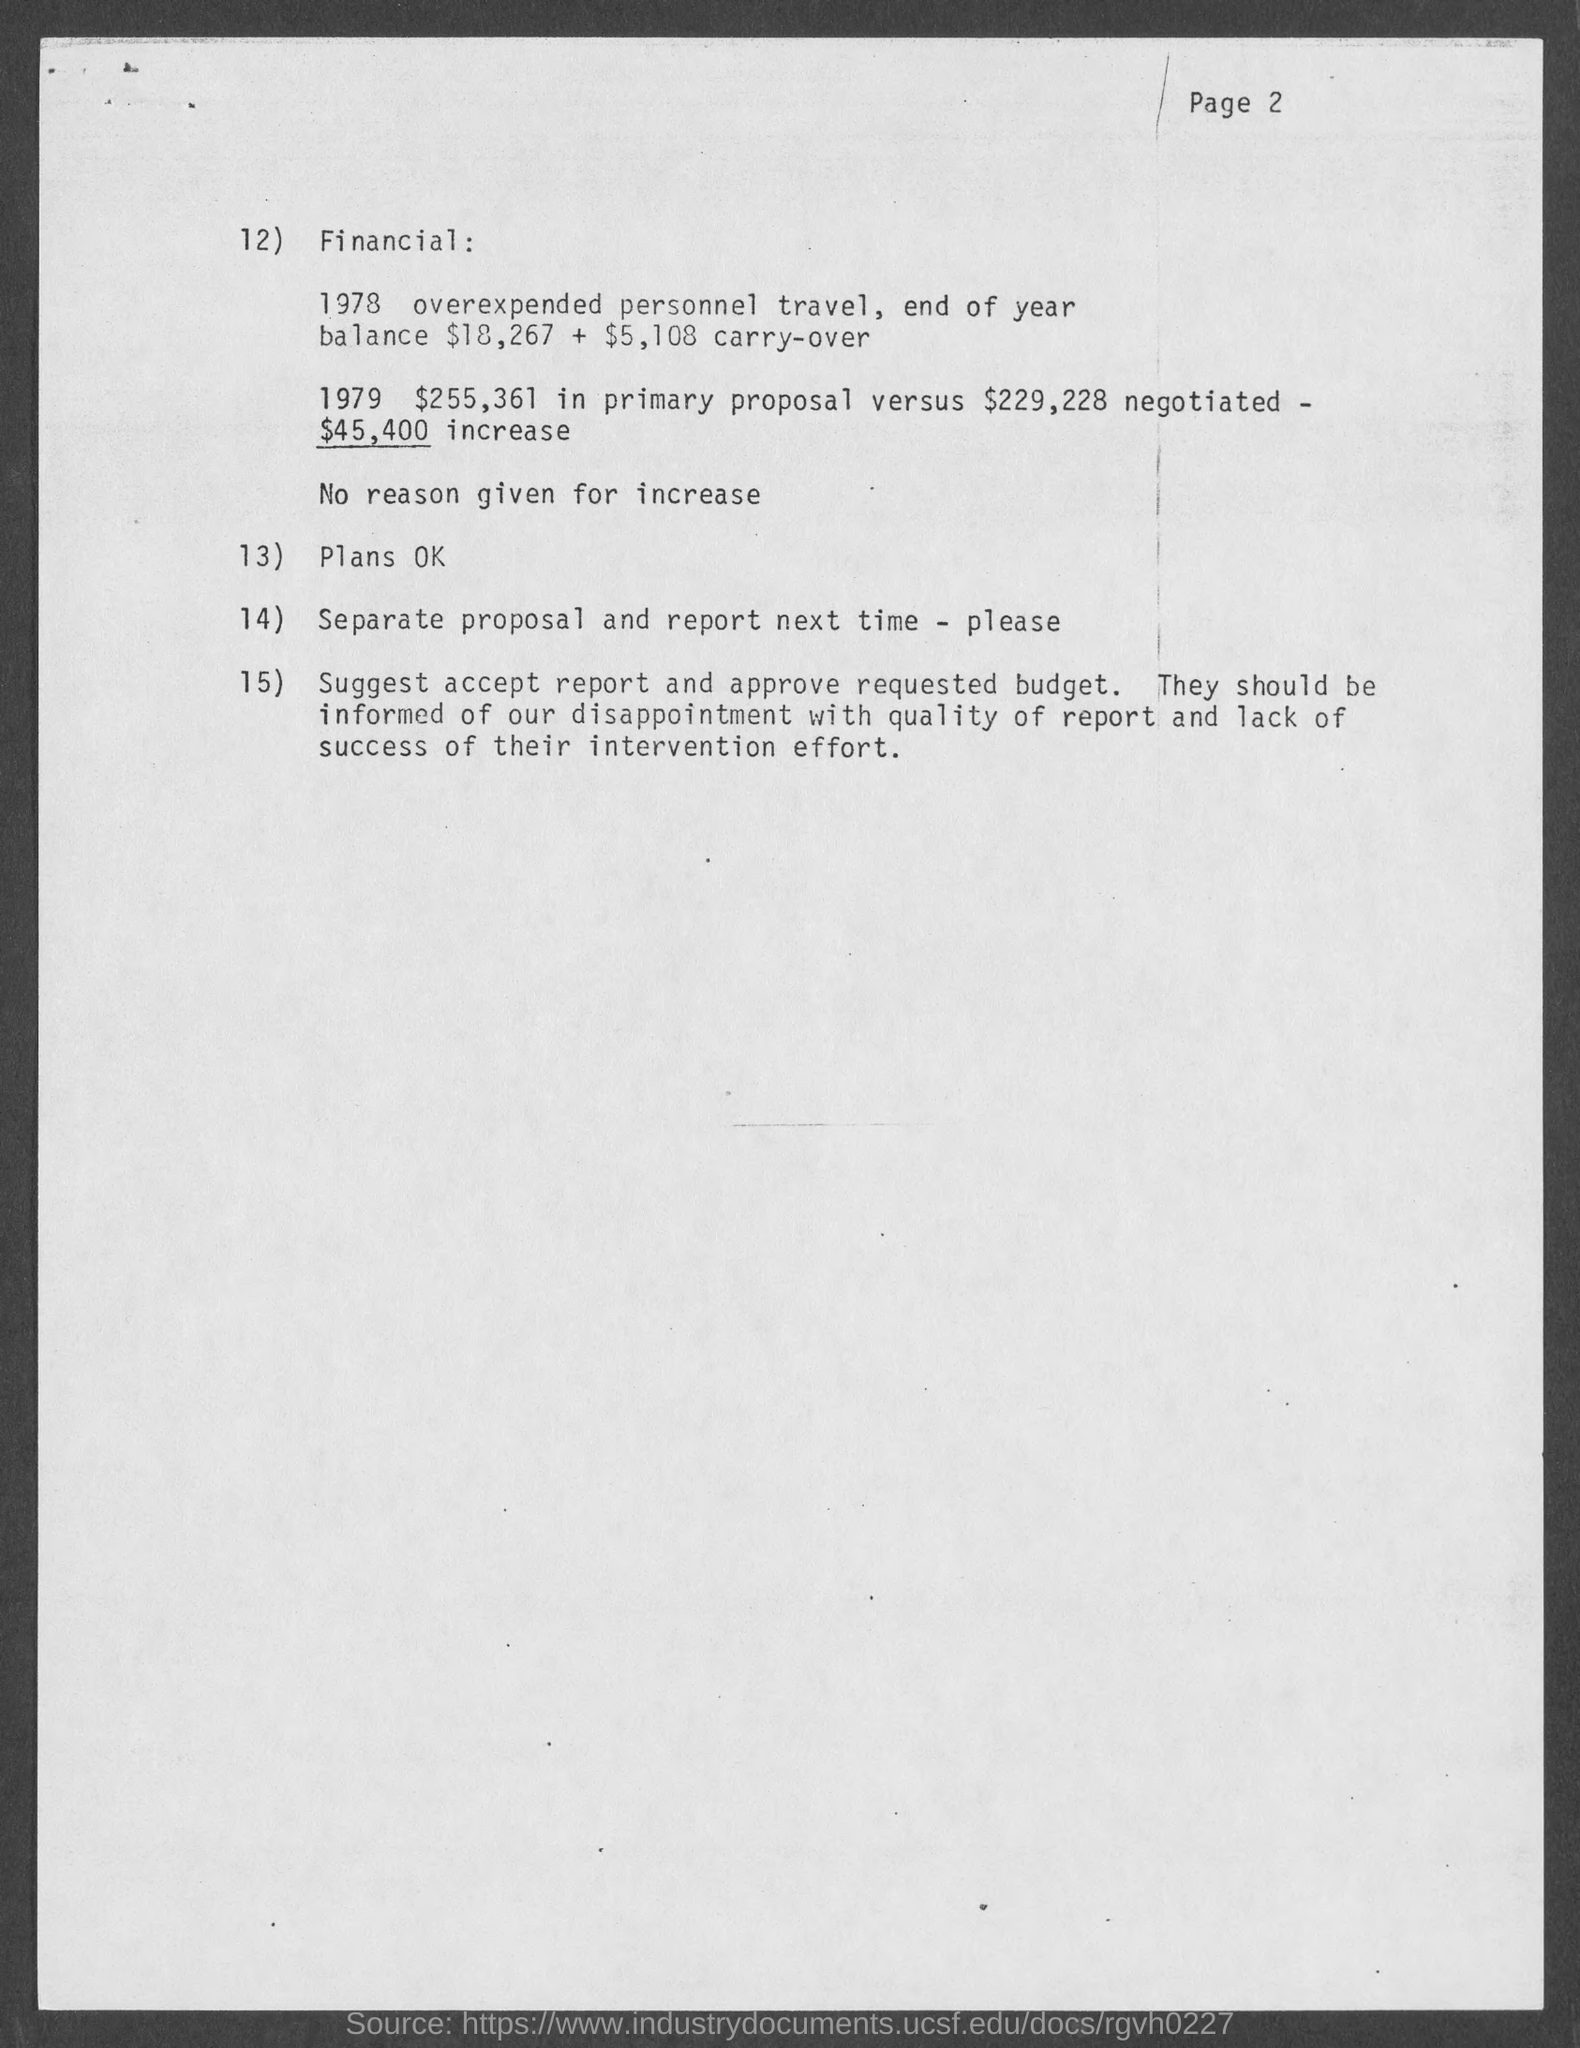What is the page number at top of the page?
Your answer should be very brief. Page 2. 